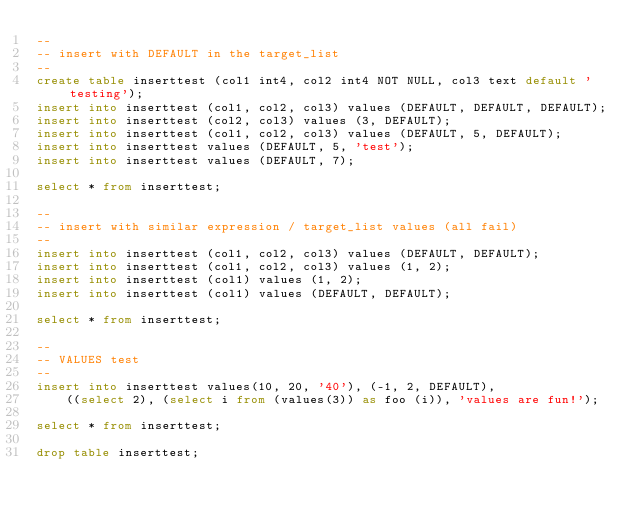<code> <loc_0><loc_0><loc_500><loc_500><_SQL_>--
-- insert with DEFAULT in the target_list
--
create table inserttest (col1 int4, col2 int4 NOT NULL, col3 text default 'testing');
insert into inserttest (col1, col2, col3) values (DEFAULT, DEFAULT, DEFAULT);
insert into inserttest (col2, col3) values (3, DEFAULT);
insert into inserttest (col1, col2, col3) values (DEFAULT, 5, DEFAULT);
insert into inserttest values (DEFAULT, 5, 'test');
insert into inserttest values (DEFAULT, 7);

select * from inserttest;

--
-- insert with similar expression / target_list values (all fail)
--
insert into inserttest (col1, col2, col3) values (DEFAULT, DEFAULT);
insert into inserttest (col1, col2, col3) values (1, 2);
insert into inserttest (col1) values (1, 2);
insert into inserttest (col1) values (DEFAULT, DEFAULT);

select * from inserttest;

--
-- VALUES test
--
insert into inserttest values(10, 20, '40'), (-1, 2, DEFAULT),
    ((select 2), (select i from (values(3)) as foo (i)), 'values are fun!');

select * from inserttest;

drop table inserttest;
</code> 